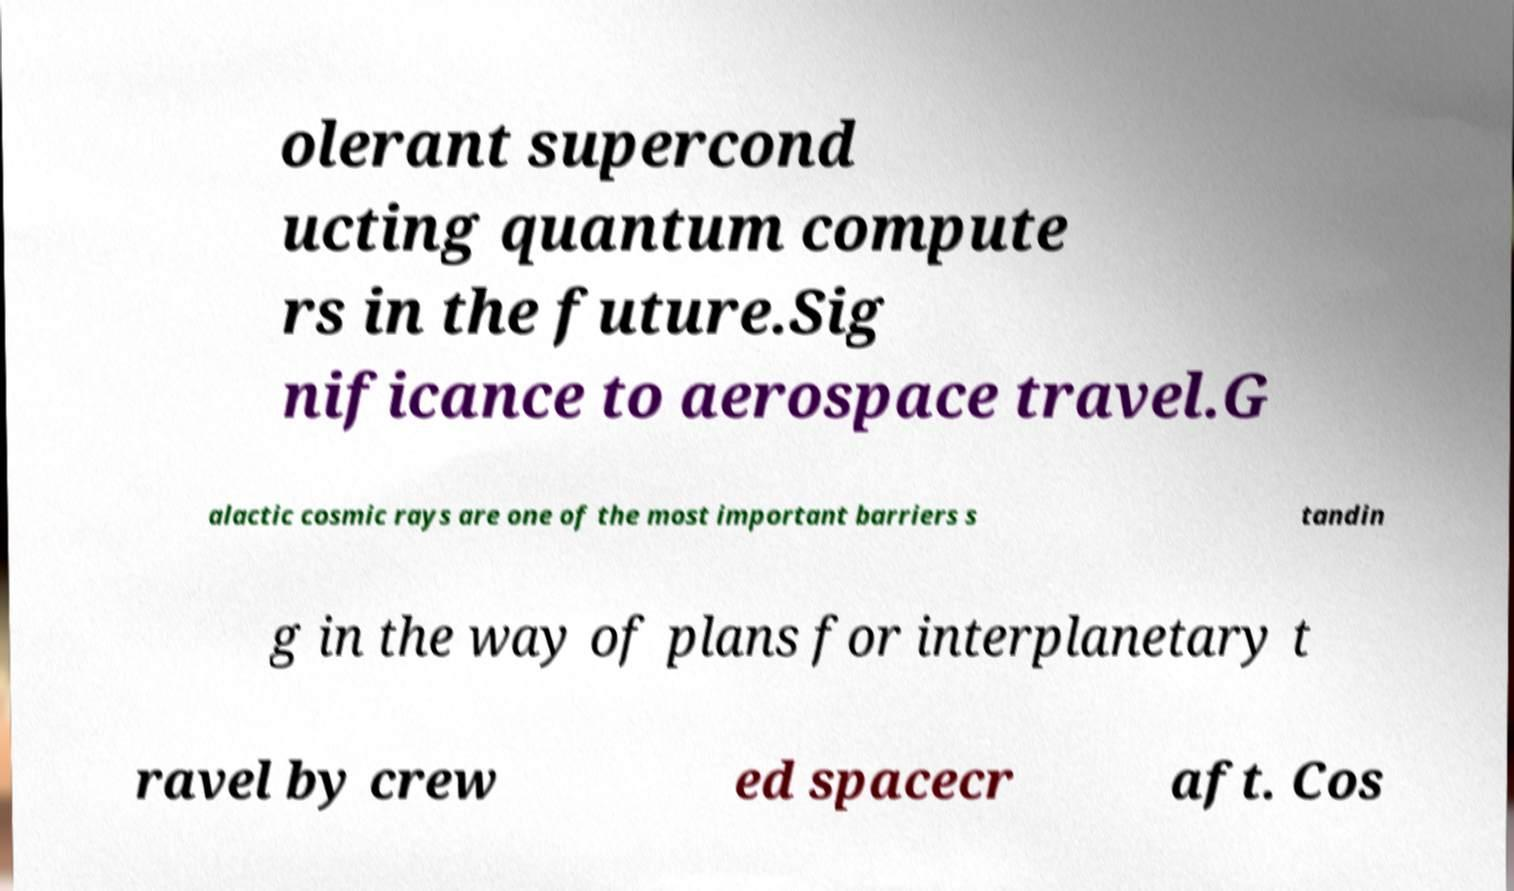Could you assist in decoding the text presented in this image and type it out clearly? olerant supercond ucting quantum compute rs in the future.Sig nificance to aerospace travel.G alactic cosmic rays are one of the most important barriers s tandin g in the way of plans for interplanetary t ravel by crew ed spacecr aft. Cos 